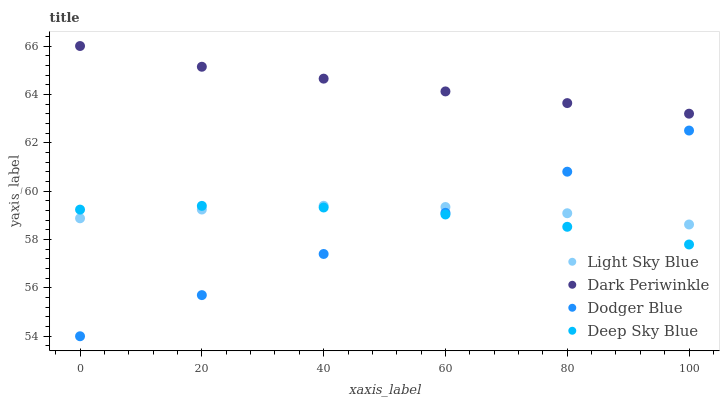Does Dodger Blue have the minimum area under the curve?
Answer yes or no. Yes. Does Dark Periwinkle have the maximum area under the curve?
Answer yes or no. Yes. Does Dark Periwinkle have the minimum area under the curve?
Answer yes or no. No. Does Dodger Blue have the maximum area under the curve?
Answer yes or no. No. Is Dodger Blue the smoothest?
Answer yes or no. Yes. Is Deep Sky Blue the roughest?
Answer yes or no. Yes. Is Dark Periwinkle the smoothest?
Answer yes or no. No. Is Dark Periwinkle the roughest?
Answer yes or no. No. Does Dodger Blue have the lowest value?
Answer yes or no. Yes. Does Dark Periwinkle have the lowest value?
Answer yes or no. No. Does Dark Periwinkle have the highest value?
Answer yes or no. Yes. Does Dodger Blue have the highest value?
Answer yes or no. No. Is Dodger Blue less than Dark Periwinkle?
Answer yes or no. Yes. Is Dark Periwinkle greater than Dodger Blue?
Answer yes or no. Yes. Does Deep Sky Blue intersect Dodger Blue?
Answer yes or no. Yes. Is Deep Sky Blue less than Dodger Blue?
Answer yes or no. No. Is Deep Sky Blue greater than Dodger Blue?
Answer yes or no. No. Does Dodger Blue intersect Dark Periwinkle?
Answer yes or no. No. 